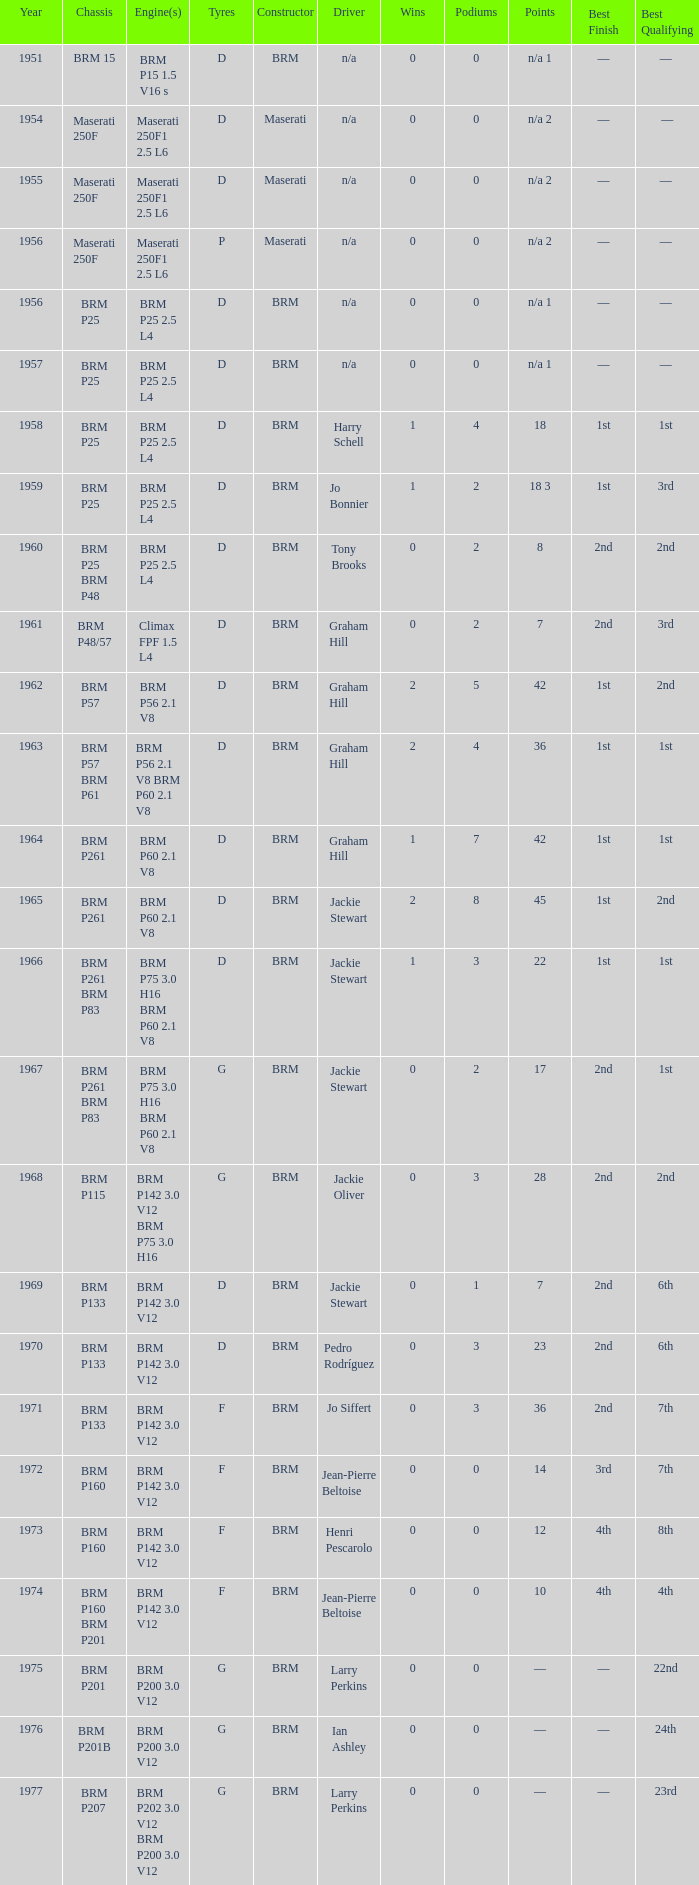Name the sum of year for engine of brm p202 3.0 v12 brm p200 3.0 v12 1977.0. 